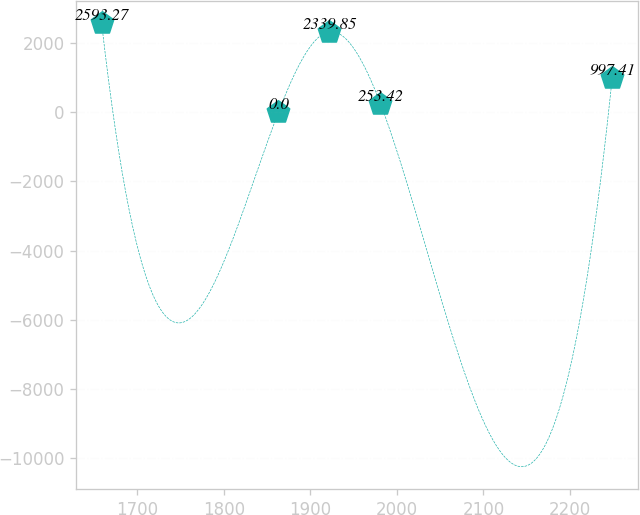Convert chart. <chart><loc_0><loc_0><loc_500><loc_500><line_chart><ecel><fcel>Unnamed: 1<nl><fcel>1658.61<fcel>2593.27<nl><fcel>1862.95<fcel>0<nl><fcel>1921.98<fcel>2339.85<nl><fcel>1981.01<fcel>253.42<nl><fcel>2248.91<fcel>997.41<nl></chart> 